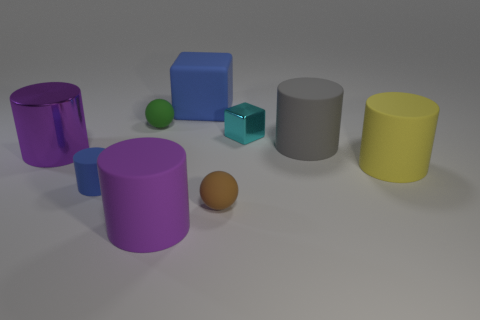There is a cyan cube that is the same size as the brown rubber thing; what is its material?
Make the answer very short. Metal. Are there any purple matte objects of the same size as the yellow cylinder?
Give a very brief answer. Yes. There is a metal object in front of the shiny block; what is its color?
Offer a very short reply. Purple. There is a purple cylinder behind the brown sphere; are there any matte things to the right of it?
Provide a short and direct response. Yes. What number of other objects are there of the same color as the big metallic thing?
Your response must be concise. 1. There is a matte sphere left of the big matte cube; is its size the same as the metal thing right of the tiny brown rubber sphere?
Your response must be concise. Yes. How big is the sphere that is on the left side of the small ball that is in front of the tiny blue matte cylinder?
Keep it short and to the point. Small. What is the small object that is on the right side of the large blue matte thing and behind the tiny brown sphere made of?
Make the answer very short. Metal. What color is the small metal object?
Give a very brief answer. Cyan. The metallic thing to the right of the small green rubber object has what shape?
Your answer should be very brief. Cube. 